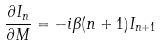Convert formula to latex. <formula><loc_0><loc_0><loc_500><loc_500>\frac { \partial I _ { n } } { \partial M } = - i \beta ( n + 1 ) I _ { n + 1 }</formula> 